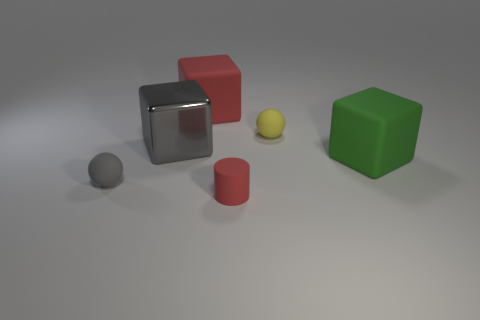The matte object that is to the left of the small yellow matte ball and behind the green matte thing is what color?
Provide a succinct answer. Red. Are there any other things that are the same material as the large gray block?
Provide a short and direct response. No. Are the green cube and the small ball in front of the green rubber cube made of the same material?
Keep it short and to the point. Yes. What size is the cube that is right of the big matte thing on the left side of the small red matte thing?
Keep it short and to the point. Large. Is there anything else that has the same color as the matte cylinder?
Make the answer very short. Yes. Do the green object that is in front of the large gray object and the object that is in front of the small gray thing have the same material?
Keep it short and to the point. Yes. The thing that is to the left of the red cylinder and behind the gray shiny thing is made of what material?
Ensure brevity in your answer.  Rubber. There is a small red thing; does it have the same shape as the matte object that is on the right side of the yellow object?
Provide a succinct answer. No. There is a ball behind the tiny object on the left side of the large matte thing on the left side of the green block; what is its material?
Offer a very short reply. Rubber. What number of other things are the same size as the green matte object?
Your answer should be compact. 2. 